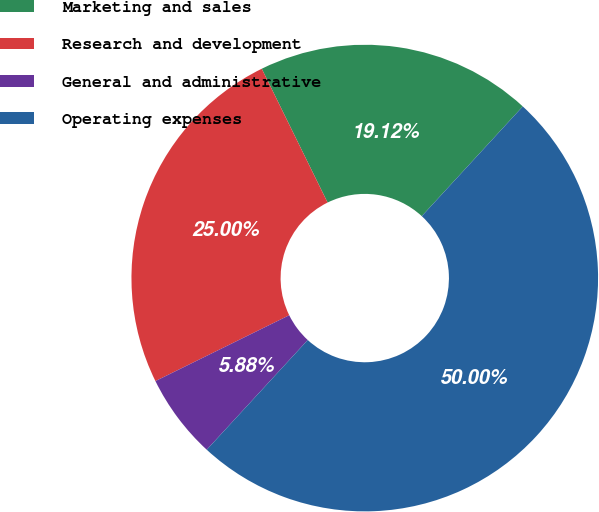Convert chart to OTSL. <chart><loc_0><loc_0><loc_500><loc_500><pie_chart><fcel>Marketing and sales<fcel>Research and development<fcel>General and administrative<fcel>Operating expenses<nl><fcel>19.12%<fcel>25.0%<fcel>5.88%<fcel>50.0%<nl></chart> 